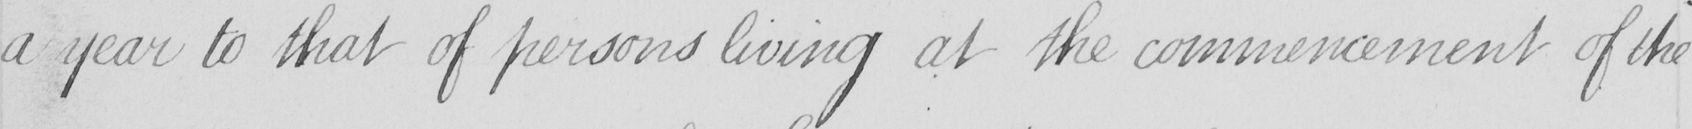Please transcribe the handwritten text in this image. a year to that of persons living at the commencement of the 